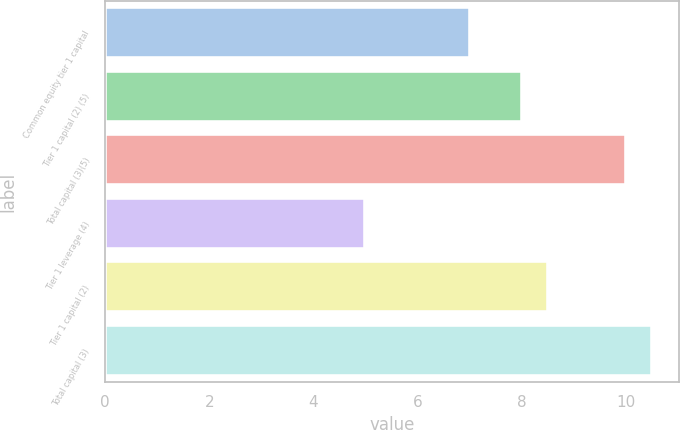Convert chart. <chart><loc_0><loc_0><loc_500><loc_500><bar_chart><fcel>Common equity tier 1 capital<fcel>Tier 1 capital (2) (5)<fcel>Total capital (3)(5)<fcel>Tier 1 leverage (4)<fcel>Tier 1 capital (2)<fcel>Total capital (3)<nl><fcel>7<fcel>8<fcel>10<fcel>5<fcel>8.5<fcel>10.5<nl></chart> 